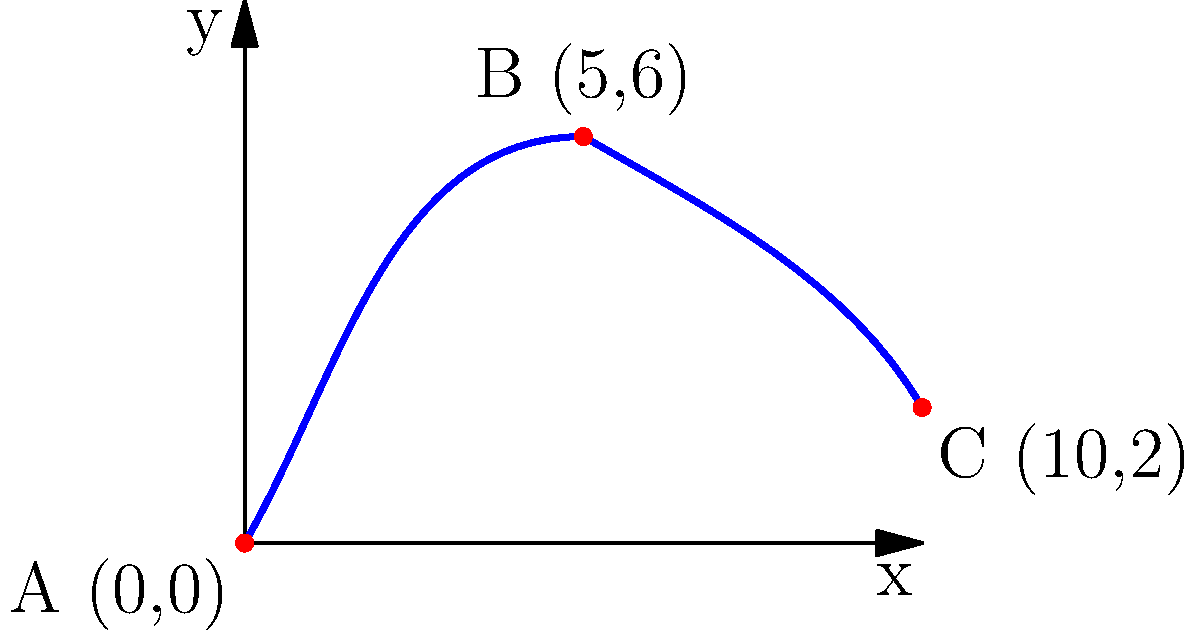A restored WWII fighter plane undergoes its first test flight after restoration. The plane's trajectory is plotted on a coordinate system where each unit represents 1 km. The plane takes off from point A (0,0), reaches its maximum altitude at point B (5,6), and lands at point C (10,2). What is the total horizontal distance covered by the plane during this test flight? To find the total horizontal distance covered by the plane, we need to focus on the x-coordinates of the given points:

1. Starting point A: x = 0 km
2. Ending point C: x = 10 km

The horizontal distance is the difference between the x-coordinates of the starting and ending points:

$$ \text{Horizontal distance} = x_C - x_A = 10 - 0 = 10 \text{ km} $$

Note that the maximum altitude point B (5,6) doesn't affect the horizontal distance calculation, as we're only concerned with the total distance from takeoff to landing along the x-axis.
Answer: 10 km 